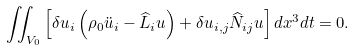Convert formula to latex. <formula><loc_0><loc_0><loc_500><loc_500>\iint _ { V _ { 0 } } \left [ \delta u _ { i } \left ( \rho _ { 0 } \ddot { u } _ { i } - \widehat { L } _ { i } u \right ) + \delta u _ { i , j } \widehat { N } _ { i j } u \right ] d x ^ { 3 } d t = 0 .</formula> 